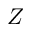<formula> <loc_0><loc_0><loc_500><loc_500>Z</formula> 